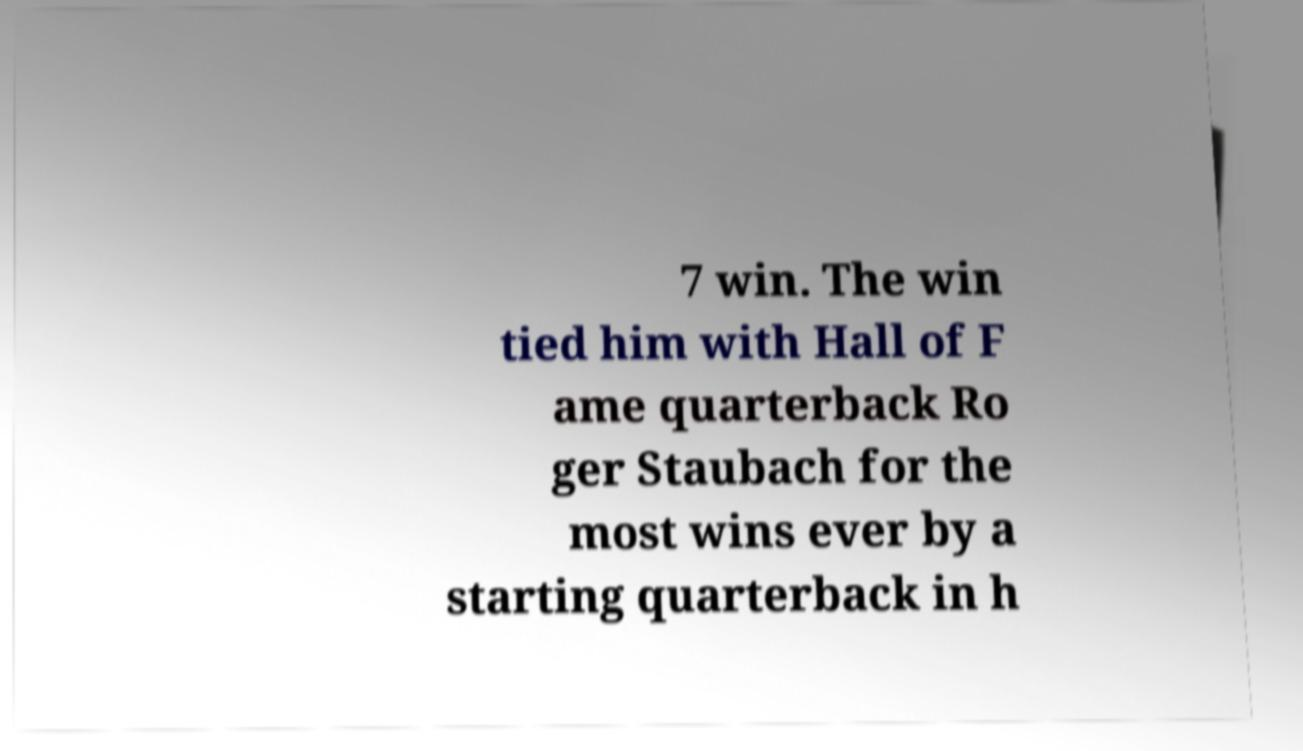Could you extract and type out the text from this image? 7 win. The win tied him with Hall of F ame quarterback Ro ger Staubach for the most wins ever by a starting quarterback in h 